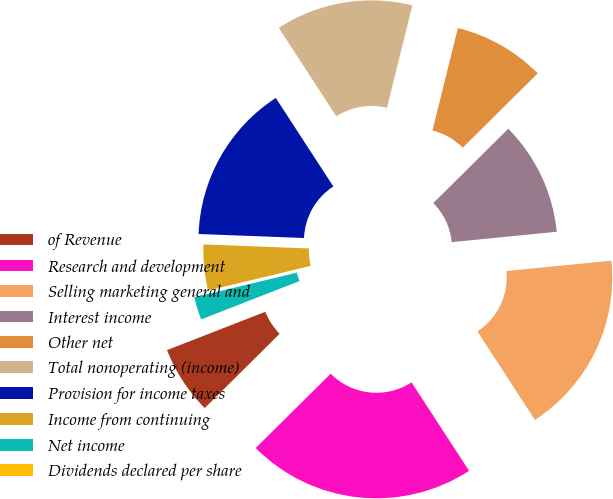Convert chart. <chart><loc_0><loc_0><loc_500><loc_500><pie_chart><fcel>of Revenue<fcel>Research and development<fcel>Selling marketing general and<fcel>Interest income<fcel>Other net<fcel>Total nonoperating (income)<fcel>Provision for income taxes<fcel>Income from continuing<fcel>Net income<fcel>Dividends declared per share<nl><fcel>6.52%<fcel>21.74%<fcel>17.39%<fcel>10.87%<fcel>8.7%<fcel>13.04%<fcel>15.22%<fcel>4.35%<fcel>2.17%<fcel>0.0%<nl></chart> 